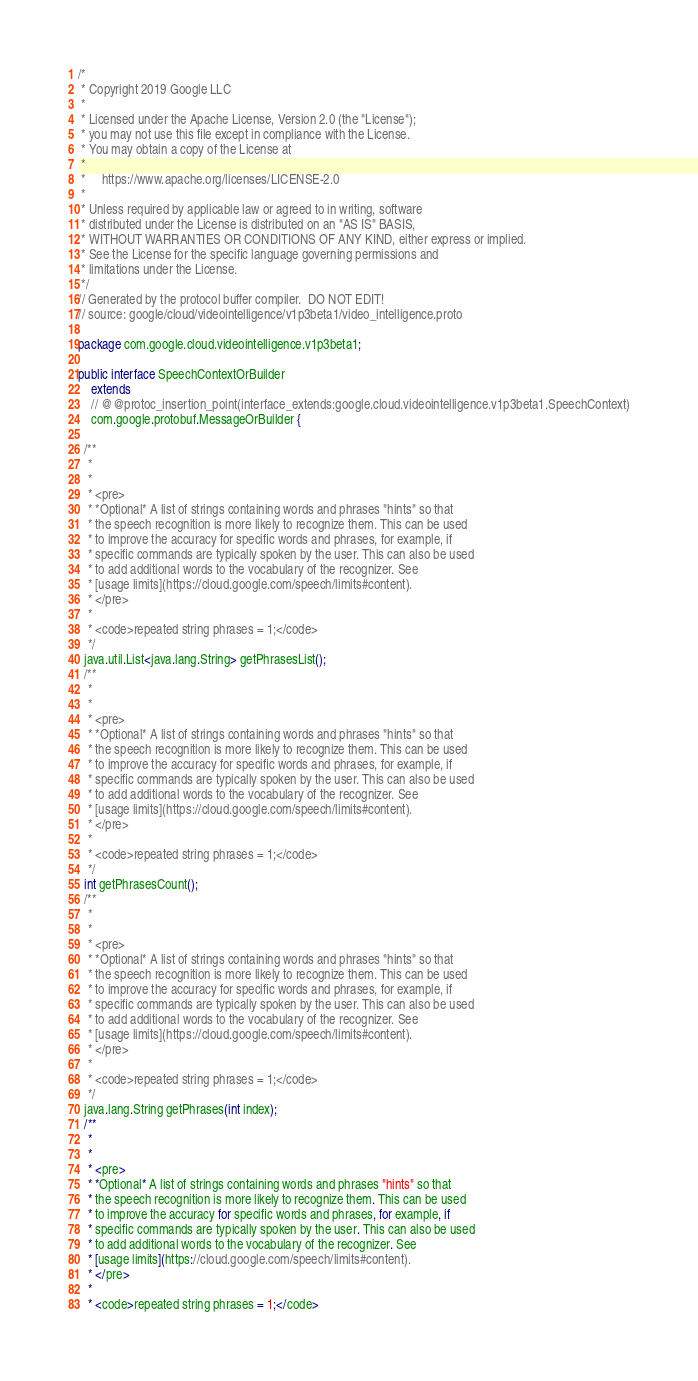Convert code to text. <code><loc_0><loc_0><loc_500><loc_500><_Java_>/*
 * Copyright 2019 Google LLC
 *
 * Licensed under the Apache License, Version 2.0 (the "License");
 * you may not use this file except in compliance with the License.
 * You may obtain a copy of the License at
 *
 *     https://www.apache.org/licenses/LICENSE-2.0
 *
 * Unless required by applicable law or agreed to in writing, software
 * distributed under the License is distributed on an "AS IS" BASIS,
 * WITHOUT WARRANTIES OR CONDITIONS OF ANY KIND, either express or implied.
 * See the License for the specific language governing permissions and
 * limitations under the License.
 */
// Generated by the protocol buffer compiler.  DO NOT EDIT!
// source: google/cloud/videointelligence/v1p3beta1/video_intelligence.proto

package com.google.cloud.videointelligence.v1p3beta1;

public interface SpeechContextOrBuilder
    extends
    // @@protoc_insertion_point(interface_extends:google.cloud.videointelligence.v1p3beta1.SpeechContext)
    com.google.protobuf.MessageOrBuilder {

  /**
   *
   *
   * <pre>
   * *Optional* A list of strings containing words and phrases "hints" so that
   * the speech recognition is more likely to recognize them. This can be used
   * to improve the accuracy for specific words and phrases, for example, if
   * specific commands are typically spoken by the user. This can also be used
   * to add additional words to the vocabulary of the recognizer. See
   * [usage limits](https://cloud.google.com/speech/limits#content).
   * </pre>
   *
   * <code>repeated string phrases = 1;</code>
   */
  java.util.List<java.lang.String> getPhrasesList();
  /**
   *
   *
   * <pre>
   * *Optional* A list of strings containing words and phrases "hints" so that
   * the speech recognition is more likely to recognize them. This can be used
   * to improve the accuracy for specific words and phrases, for example, if
   * specific commands are typically spoken by the user. This can also be used
   * to add additional words to the vocabulary of the recognizer. See
   * [usage limits](https://cloud.google.com/speech/limits#content).
   * </pre>
   *
   * <code>repeated string phrases = 1;</code>
   */
  int getPhrasesCount();
  /**
   *
   *
   * <pre>
   * *Optional* A list of strings containing words and phrases "hints" so that
   * the speech recognition is more likely to recognize them. This can be used
   * to improve the accuracy for specific words and phrases, for example, if
   * specific commands are typically spoken by the user. This can also be used
   * to add additional words to the vocabulary of the recognizer. See
   * [usage limits](https://cloud.google.com/speech/limits#content).
   * </pre>
   *
   * <code>repeated string phrases = 1;</code>
   */
  java.lang.String getPhrases(int index);
  /**
   *
   *
   * <pre>
   * *Optional* A list of strings containing words and phrases "hints" so that
   * the speech recognition is more likely to recognize them. This can be used
   * to improve the accuracy for specific words and phrases, for example, if
   * specific commands are typically spoken by the user. This can also be used
   * to add additional words to the vocabulary of the recognizer. See
   * [usage limits](https://cloud.google.com/speech/limits#content).
   * </pre>
   *
   * <code>repeated string phrases = 1;</code></code> 